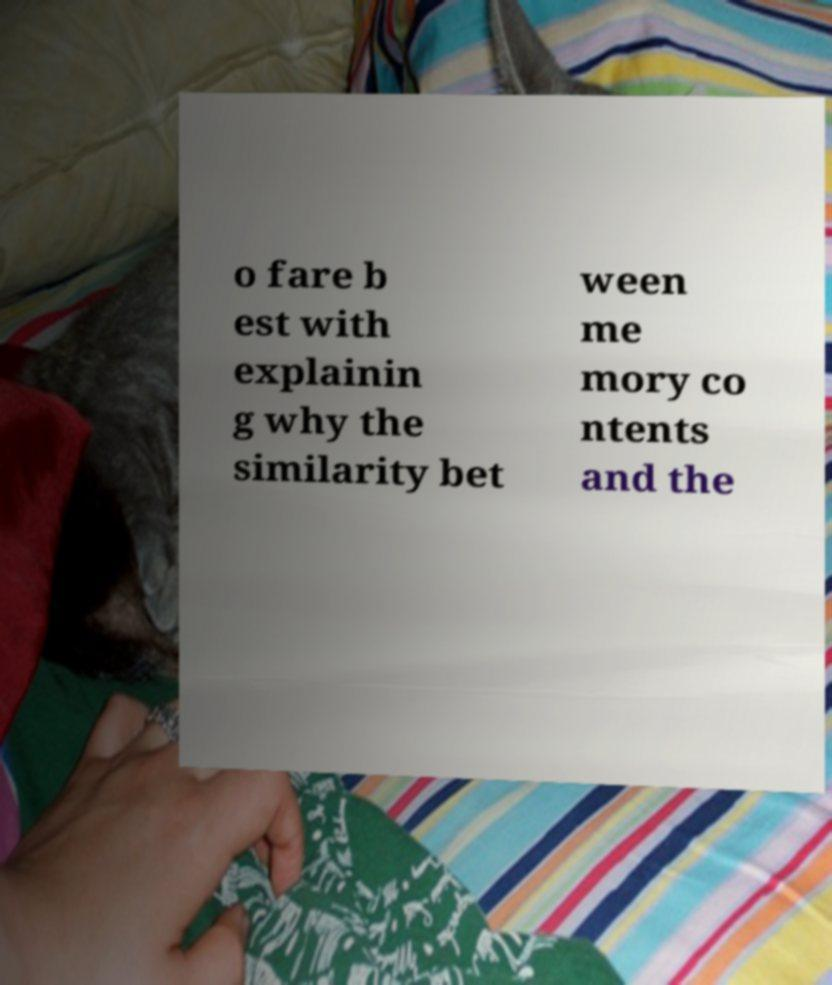What messages or text are displayed in this image? I need them in a readable, typed format. o fare b est with explainin g why the similarity bet ween me mory co ntents and the 